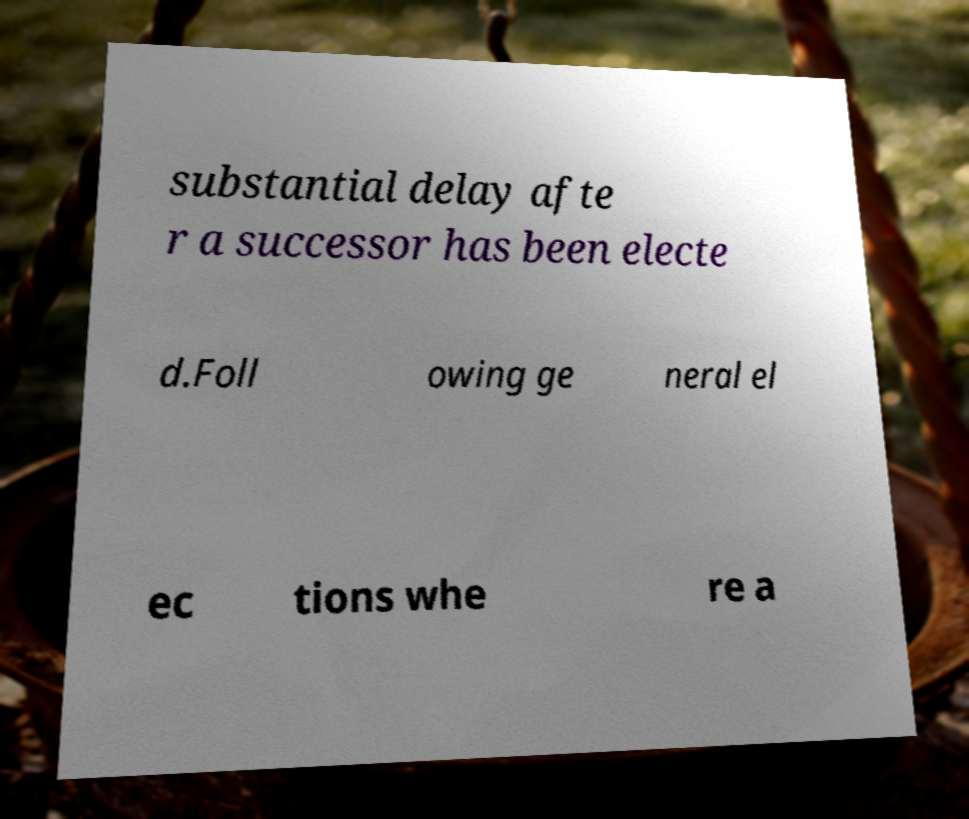There's text embedded in this image that I need extracted. Can you transcribe it verbatim? substantial delay afte r a successor has been electe d.Foll owing ge neral el ec tions whe re a 